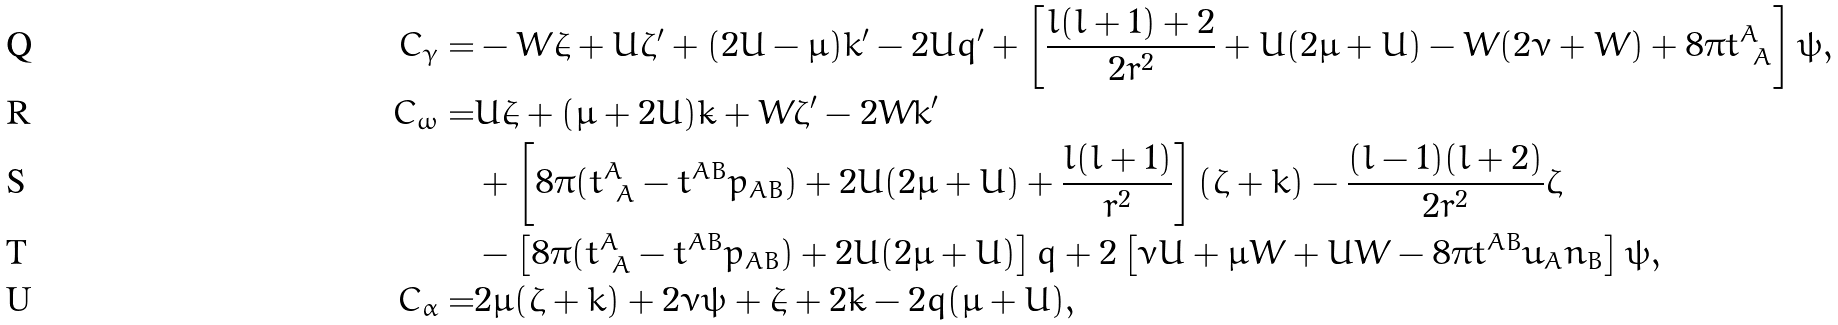<formula> <loc_0><loc_0><loc_500><loc_500>C _ { \gamma } = & - W \dot { \zeta } + U \zeta ^ { \prime } + ( 2 U - \mu ) k ^ { \prime } - 2 U q ^ { \prime } + \left [ \frac { l ( l + 1 ) + 2 } { 2 r ^ { 2 } } + U ( 2 \mu + U ) - W ( 2 \nu + W ) + 8 \pi t ^ { A } _ { \ A } \right ] \psi , \\ C _ { \omega } = & U \dot { \zeta } + ( \mu + 2 U ) \dot { k } + W \zeta ^ { \prime } - 2 W k ^ { \prime } \\ & + \left [ 8 \pi ( t ^ { A } _ { \ A } - t ^ { A B } p _ { A B } ) + 2 U ( 2 \mu + U ) + \frac { l ( l + 1 ) } { r ^ { 2 } } \right ] ( \zeta + k ) - \frac { ( l - 1 ) ( l + 2 ) } { 2 r ^ { 2 } } \zeta \\ & - \left [ 8 \pi ( t ^ { A } _ { \ A } - t ^ { A B } p _ { A B } ) + 2 U ( 2 \mu + U ) \right ] q + 2 \left [ \nu U + \mu W + U W - 8 \pi t ^ { A B } u _ { A } n _ { B } \right ] \psi , \\ C _ { \alpha } = & 2 \mu ( \zeta + k ) + 2 \nu \psi + \dot { \zeta } + 2 \dot { k } - 2 q ( \mu + U ) ,</formula> 